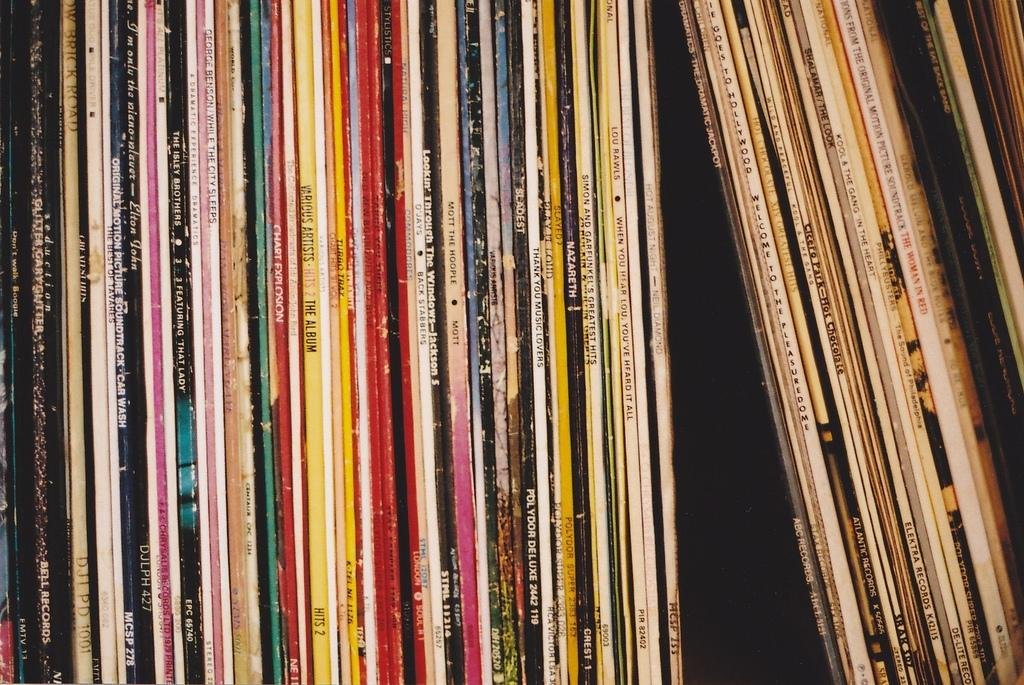<image>
Relay a brief, clear account of the picture shown. a collection of old albums from such artists as NAZARETH, The Isley Brothers, Kool & the Gang, etc. 